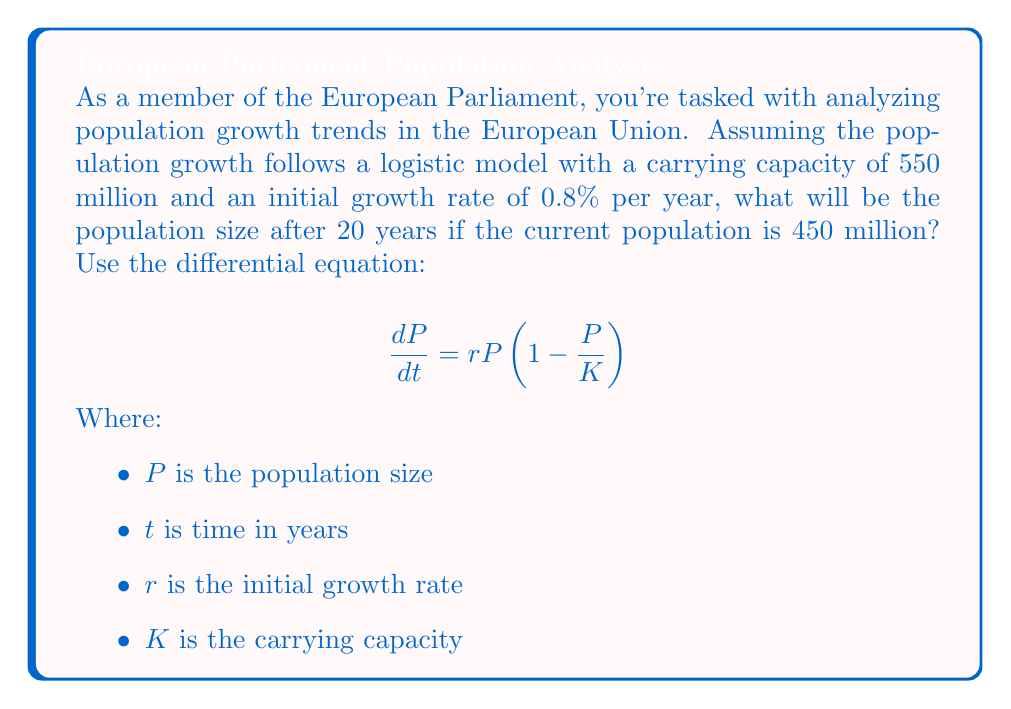Show me your answer to this math problem. To solve this problem, we'll use the logistic growth model:

1) First, let's identify our parameters:
   $K = 550$ million (carrying capacity)
   $r = 0.008$ (0.8% growth rate)
   $P_0 = 450$ million (initial population)
   $t = 20$ years

2) The solution to the logistic differential equation is:

   $$P(t) = \frac{K}{1 + (\frac{K}{P_0} - 1)e^{-rt}}$$

3) Let's substitute our values:

   $$P(20) = \frac{550}{1 + (\frac{550}{450} - 1)e^{-0.008 \cdot 20}}$$

4) Simplify:
   $$P(20) = \frac{550}{1 + (\frac{11}{9} - 1)e^{-0.16}}$$
   $$P(20) = \frac{550}{1 + \frac{2}{9}e^{-0.16}}$$

5) Calculate:
   $$P(20) \approx 494.76$$ million

6) Round to the nearest million:
   $$P(20) \approx 495$$ million
Answer: 495 million 